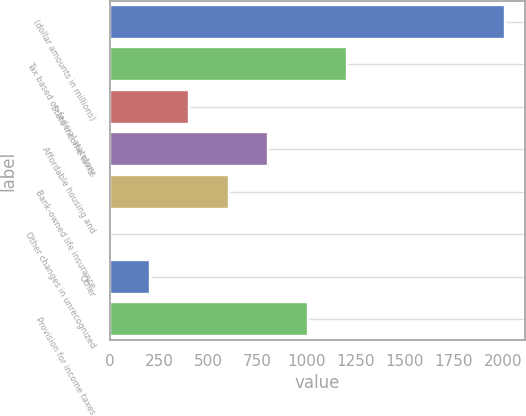Convert chart to OTSL. <chart><loc_0><loc_0><loc_500><loc_500><bar_chart><fcel>(dollar amounts in millions)<fcel>Tax based on federal statutory<fcel>State income taxes<fcel>Affordable housing and<fcel>Bank-owned life insurance<fcel>Other changes in unrecognized<fcel>Other<fcel>Provision for income taxes<nl><fcel>2012<fcel>1207.28<fcel>402.56<fcel>804.92<fcel>603.74<fcel>0.2<fcel>201.38<fcel>1006.1<nl></chart> 